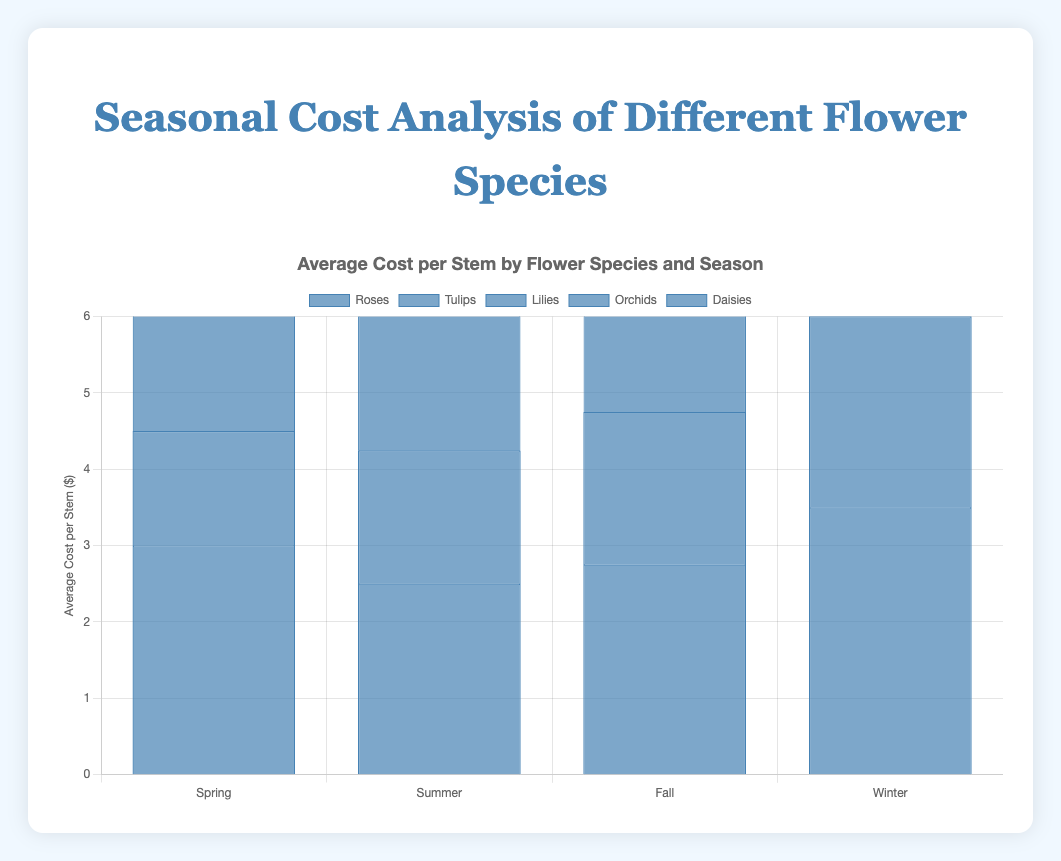Which flower species has the highest average cost per stem in Winter? By referring to the Winter season costs on the chart, we see that Orchids have the highest bar indicating the highest cost per stem.
Answer: Orchids What is the difference in average cost per stem between Tulips in Spring and Winter? Look at the bars for Tulips in Spring and Winter; Spring is $1.50 and Winter is $2.50. The difference is $2.50 - $1.50.
Answer: $1.00 Which season shows the highest average cost for Lilies? Check the bars representing Lilies across different seasons; Winter has the highest bar.
Answer: Winter Are there any flower species whose cost per stem does not increase in the Winter? By checking each flower species cost in Winter compared to other seasons, we see that all costs increase in Winter.
Answer: No What is the average cost per stem for Daisies across all seasons? Add up the costs for Daisies in each season ($1.00 + $1.25 + $1.50 + $1.75) and divide by 4.
Answer: $1.375 Between Tulips and Roses, which has a lower cost per stem in Summer? Compare the bars for Tulips and Roses in Summer; Tulips are $1.75, and Roses are $2.50. Tulips have a lower cost.
Answer: Tulips By how much does the average cost per stem of Orchids change from Summer to Winter? Find the costs for Orchids in Summer and Winter; $4.50 in Summer and $5.50 in Winter. The change is $5.50 - $4.50.
Answer: $1.00 Which flower species has the least average cost per stem in Fall? Look at the Fall bars and identify the lowest one, which belongs to Daisies.
Answer: Daisies What is the combined average cost per stem for Lilies and Roses in Spring? Sum up the Spring costs for Lilies ($3.50) and Roses ($3.00).
Answer: $6.50 Is there any season where the average cost per stem for Tulips is higher than for Roses? Compare the bars for Tulips and Roses across all seasons. None of Tulips' bars are higher than those for Roses.
Answer: No 